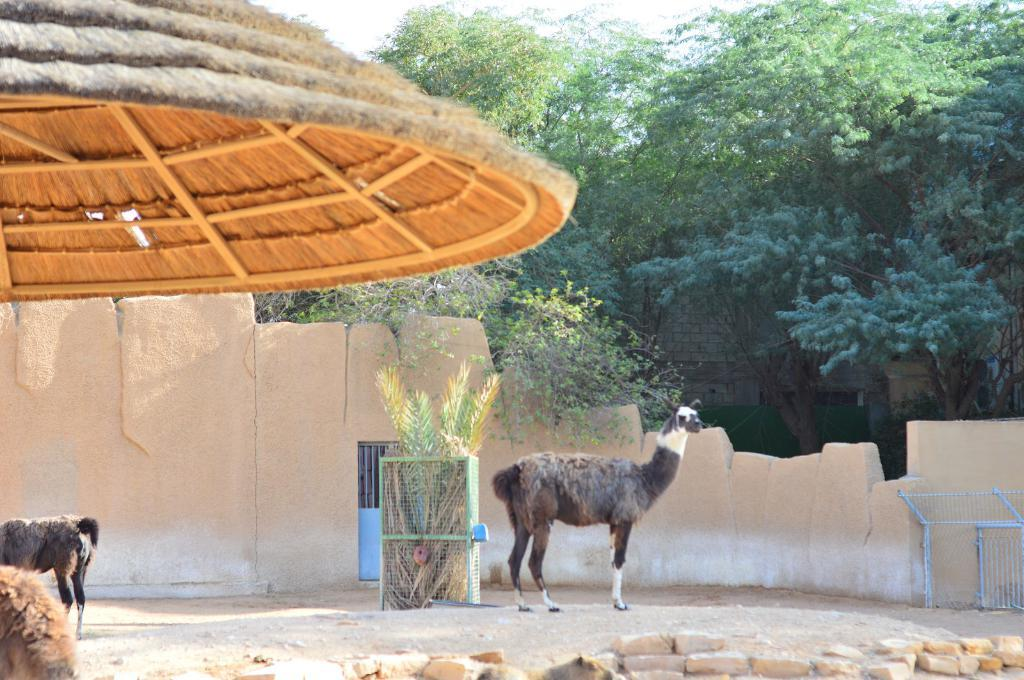What type of structure is in the image? There is a hut in the image. What can be seen on the road in the image? Animals are standing on the road in the image. What type of material is present in the image? Stones are present in the image. What type of architectural feature is visible in the image? Walls are visible in the image. What type of vegetation is present in the image? Trees are present in the image. What type of man-made structures are visible in the image? Buildings are visible in the image. What part of the natural environment is visible in the image? The sky is visible in the image. How many pizzas are being served in the hut in the image? There is no mention of pizzas in the image; it only features a hut, animals, stones, walls, trees, buildings, and the sky. Can you see a rat in the image? There is no rat present in the image. 